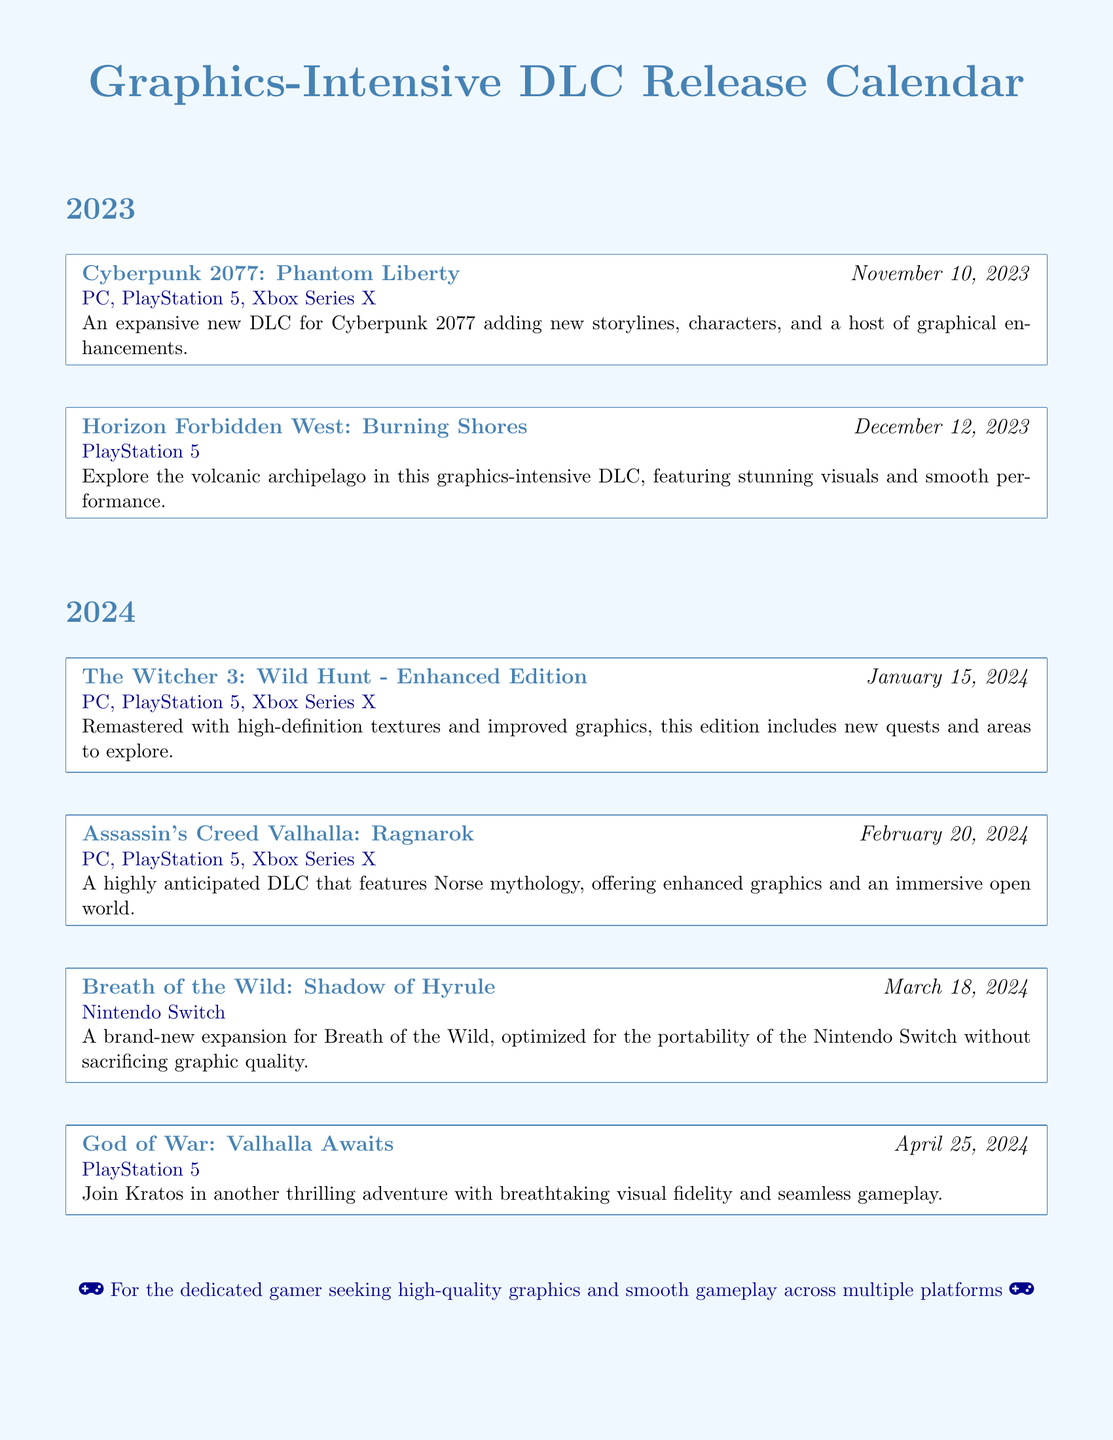what is the release date of Cyberpunk 2077: Phantom Liberty? The release date for Cyberpunk 2077: Phantom Liberty is mentioned in the document as November 10, 2023.
Answer: November 10, 2023 which platforms are supported for Horizon Forbidden West: Burning Shores? The supported platforms are specifically listed in the document for Horizon Forbidden West: Burning Shores, which are PlayStation 5.
Answer: PlayStation 5 what is a key feature of The Witcher 3: Wild Hunt - Enhanced Edition? A key feature highlighted in the document is that it includes remastered high-definition textures and improved graphics, along with new quests.
Answer: High-definition textures and improved graphics which game has a graphics-intensive DLC releasing on December 12, 2023? The document specifies the game as Horizon Forbidden West with its DLC releasing on that date.
Answer: Horizon Forbidden West how many DLC entries are listed for 2024? By counting the entries in the document, we find that there are four DLCs listed for the year 2024.
Answer: Four what is the title of the expansion for Breath of the Wild? The title of the expansion provided in the document is Shadow of Hyrule.
Answer: Shadow of Hyrule how does Breath of the Wild: Shadow of Hyrule maintain graphic quality? The document mentions that it is optimized for the Nintendo Switch's portability without sacrificing graphic quality.
Answer: Optimized for portability without sacrificing graphic quality what type of document is this? The document is specifically a release calendar focusing on graphics-intensive DLCs.
Answer: Release calendar 